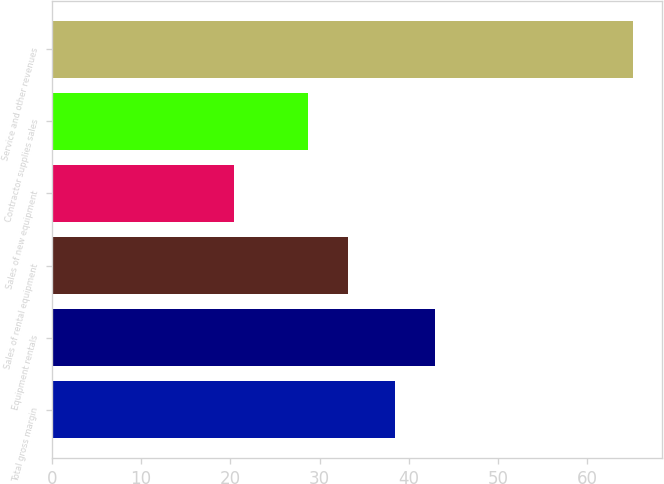Convert chart to OTSL. <chart><loc_0><loc_0><loc_500><loc_500><bar_chart><fcel>Total gross margin<fcel>Equipment rentals<fcel>Sales of rental equipment<fcel>Sales of new equipment<fcel>Contractor supplies sales<fcel>Service and other revenues<nl><fcel>38.5<fcel>42.97<fcel>33.17<fcel>20.4<fcel>28.7<fcel>65.1<nl></chart> 